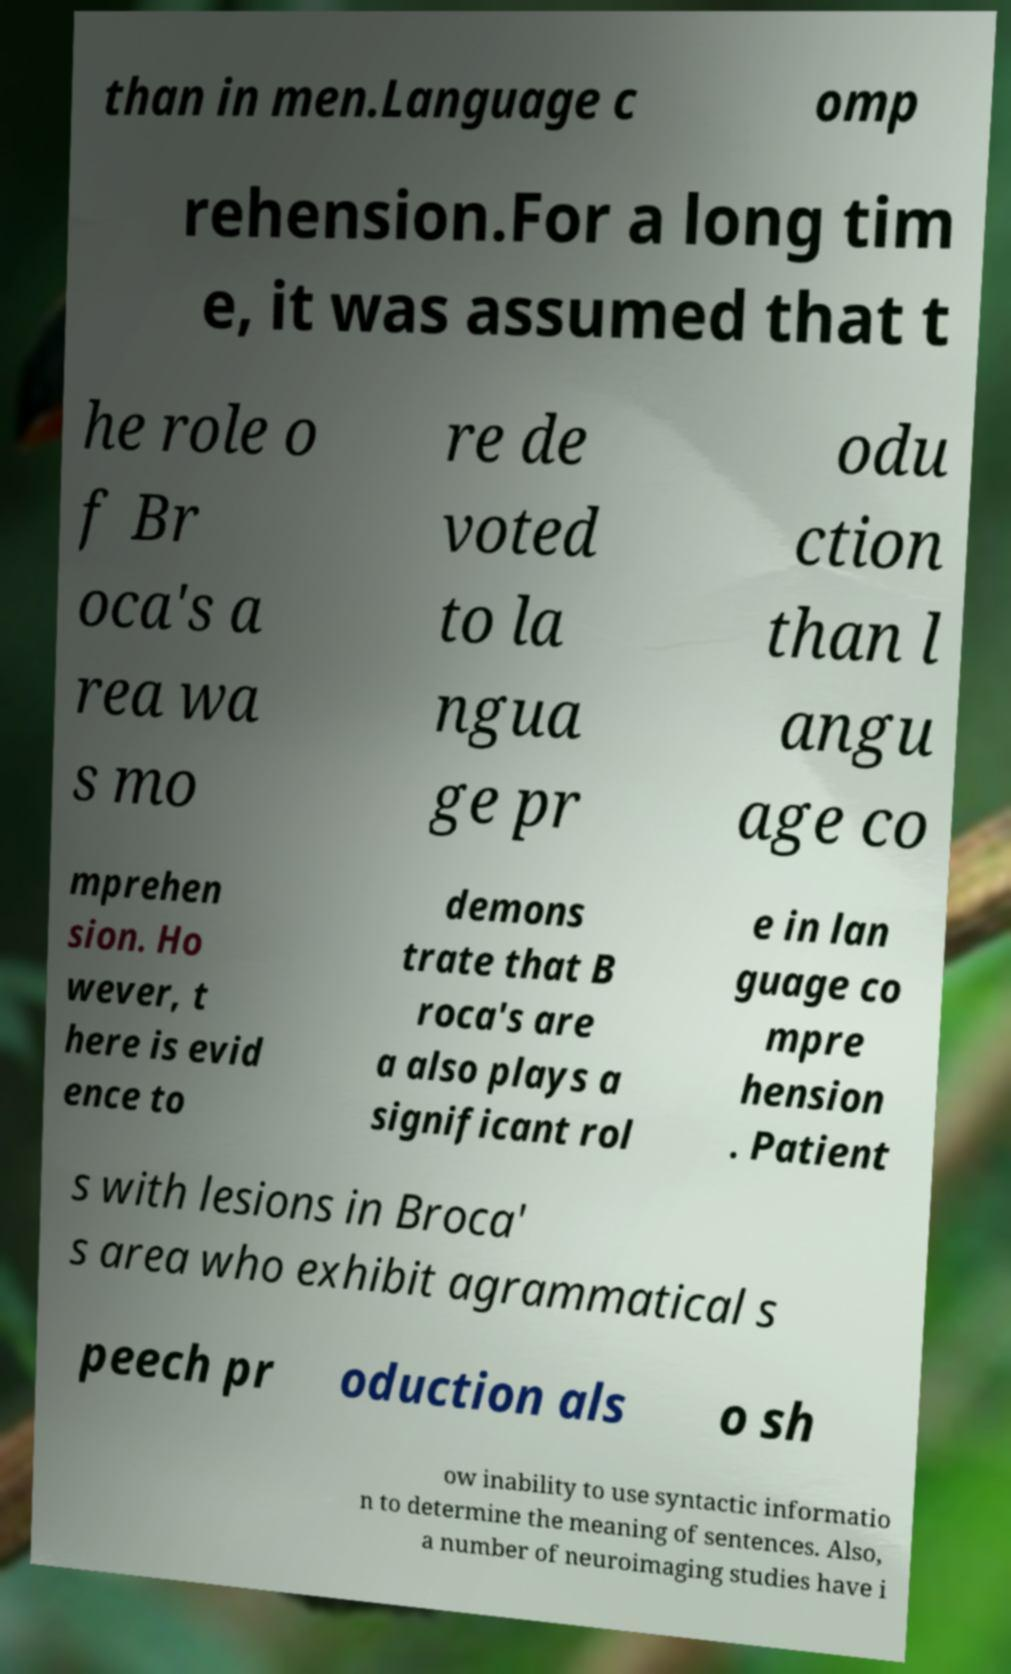Can you read and provide the text displayed in the image?This photo seems to have some interesting text. Can you extract and type it out for me? than in men.Language c omp rehension.For a long tim e, it was assumed that t he role o f Br oca's a rea wa s mo re de voted to la ngua ge pr odu ction than l angu age co mprehen sion. Ho wever, t here is evid ence to demons trate that B roca's are a also plays a significant rol e in lan guage co mpre hension . Patient s with lesions in Broca' s area who exhibit agrammatical s peech pr oduction als o sh ow inability to use syntactic informatio n to determine the meaning of sentences. Also, a number of neuroimaging studies have i 